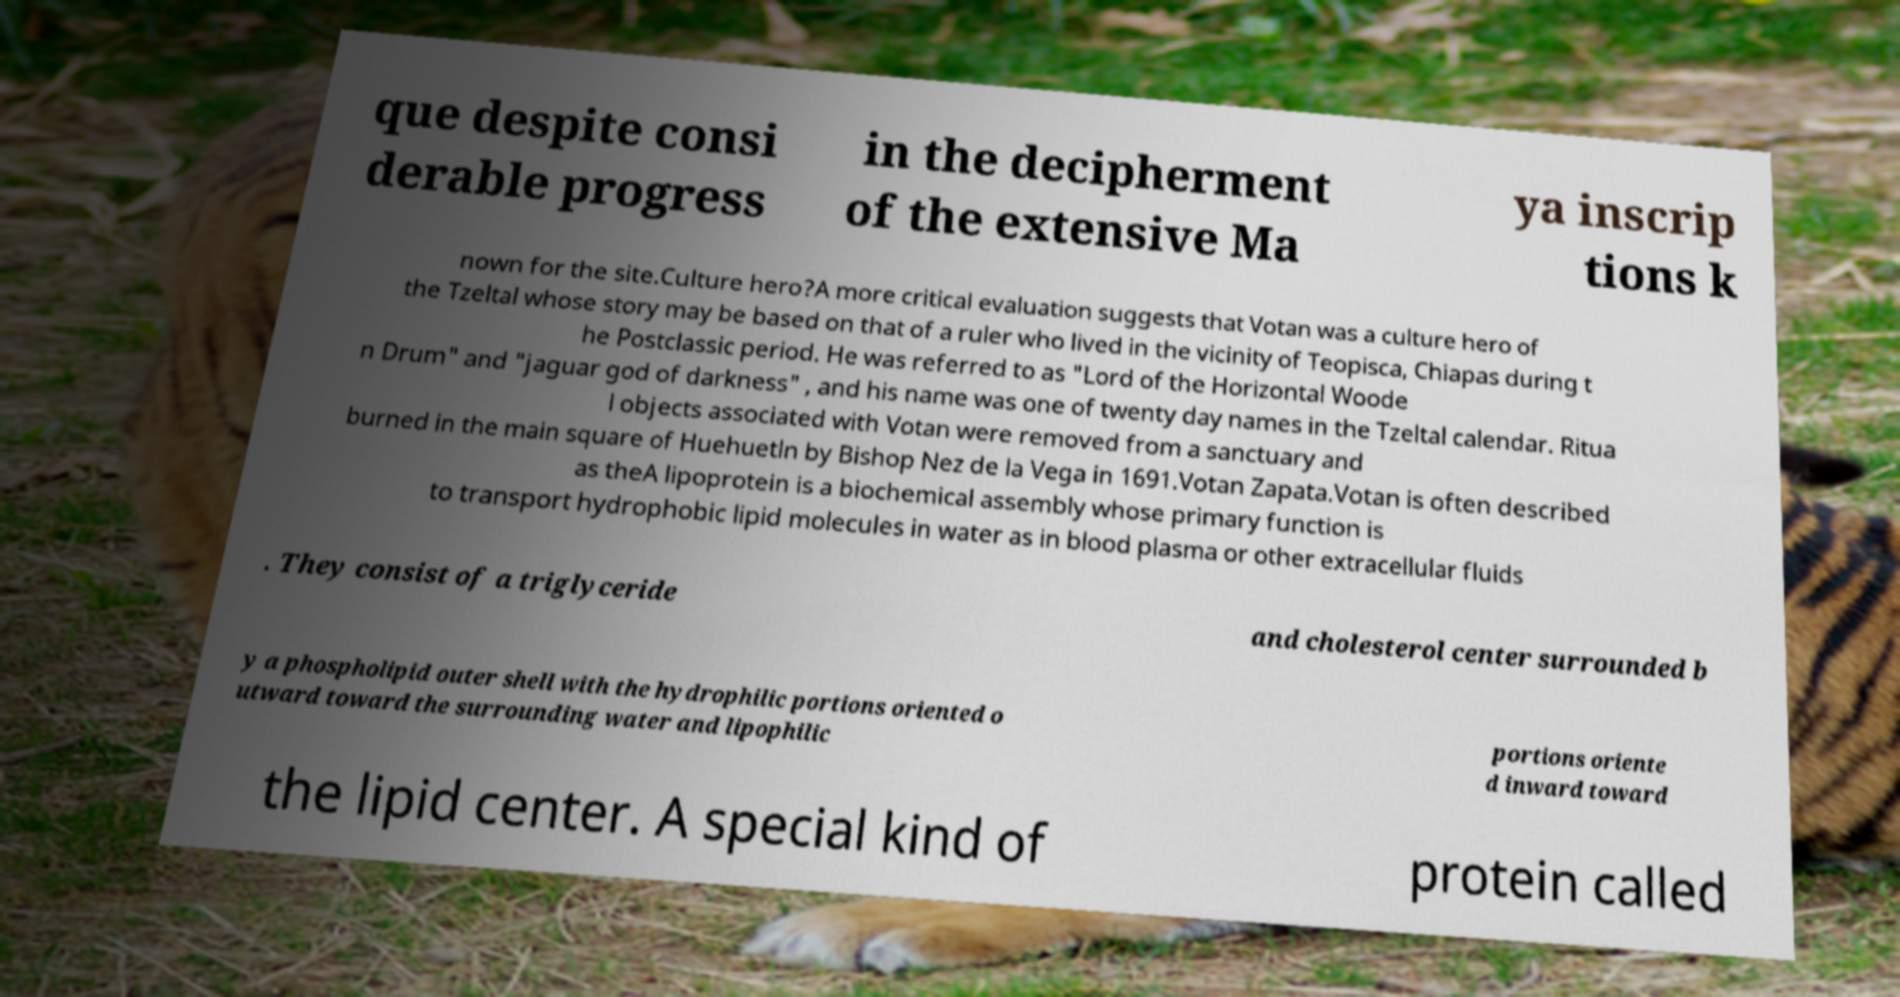Please read and relay the text visible in this image. What does it say? que despite consi derable progress in the decipherment of the extensive Ma ya inscrip tions k nown for the site.Culture hero?A more critical evaluation suggests that Votan was a culture hero of the Tzeltal whose story may be based on that of a ruler who lived in the vicinity of Teopisca, Chiapas during t he Postclassic period. He was referred to as "Lord of the Horizontal Woode n Drum" and "jaguar god of darkness" , and his name was one of twenty day names in the Tzeltal calendar. Ritua l objects associated with Votan were removed from a sanctuary and burned in the main square of Huehuetln by Bishop Nez de la Vega in 1691.Votan Zapata.Votan is often described as theA lipoprotein is a biochemical assembly whose primary function is to transport hydrophobic lipid molecules in water as in blood plasma or other extracellular fluids . They consist of a triglyceride and cholesterol center surrounded b y a phospholipid outer shell with the hydrophilic portions oriented o utward toward the surrounding water and lipophilic portions oriente d inward toward the lipid center. A special kind of protein called 